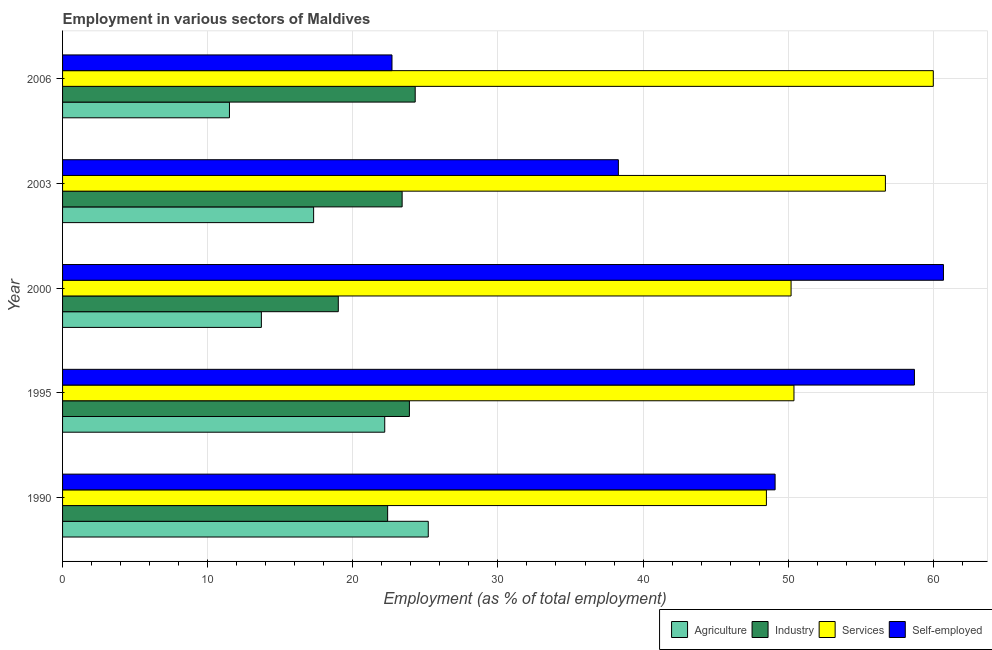How many bars are there on the 3rd tick from the bottom?
Your response must be concise. 4. In how many cases, is the number of bars for a given year not equal to the number of legend labels?
Keep it short and to the point. 0. What is the percentage of workers in agriculture in 1990?
Your answer should be very brief. 25.2. Across all years, what is the maximum percentage of workers in industry?
Give a very brief answer. 24.3. Across all years, what is the minimum percentage of self employed workers?
Offer a very short reply. 22.7. In which year was the percentage of workers in agriculture maximum?
Provide a short and direct response. 1990. What is the total percentage of workers in industry in the graph?
Ensure brevity in your answer.  113. What is the difference between the percentage of workers in industry in 2000 and the percentage of workers in agriculture in 1990?
Your response must be concise. -6.2. What is the average percentage of workers in agriculture per year?
Give a very brief answer. 17.98. In how many years, is the percentage of workers in industry greater than 22 %?
Offer a terse response. 4. What is the ratio of the percentage of workers in services in 2000 to that in 2003?
Make the answer very short. 0.89. What is the difference between the highest and the second highest percentage of workers in industry?
Your response must be concise. 0.4. What is the difference between the highest and the lowest percentage of workers in agriculture?
Your response must be concise. 13.7. In how many years, is the percentage of workers in industry greater than the average percentage of workers in industry taken over all years?
Make the answer very short. 3. Is the sum of the percentage of self employed workers in 1995 and 2000 greater than the maximum percentage of workers in services across all years?
Your answer should be very brief. Yes. What does the 2nd bar from the top in 2003 represents?
Give a very brief answer. Services. What does the 4th bar from the bottom in 1990 represents?
Your response must be concise. Self-employed. How many bars are there?
Your answer should be compact. 20. How many years are there in the graph?
Your answer should be compact. 5. Does the graph contain grids?
Give a very brief answer. Yes. Where does the legend appear in the graph?
Your answer should be compact. Bottom right. How are the legend labels stacked?
Provide a succinct answer. Horizontal. What is the title of the graph?
Give a very brief answer. Employment in various sectors of Maldives. Does "Revenue mobilization" appear as one of the legend labels in the graph?
Ensure brevity in your answer.  No. What is the label or title of the X-axis?
Your answer should be compact. Employment (as % of total employment). What is the Employment (as % of total employment) in Agriculture in 1990?
Ensure brevity in your answer.  25.2. What is the Employment (as % of total employment) of Industry in 1990?
Give a very brief answer. 22.4. What is the Employment (as % of total employment) in Services in 1990?
Your answer should be compact. 48.5. What is the Employment (as % of total employment) in Self-employed in 1990?
Your response must be concise. 49.1. What is the Employment (as % of total employment) of Agriculture in 1995?
Offer a very short reply. 22.2. What is the Employment (as % of total employment) of Industry in 1995?
Make the answer very short. 23.9. What is the Employment (as % of total employment) of Services in 1995?
Provide a succinct answer. 50.4. What is the Employment (as % of total employment) in Self-employed in 1995?
Ensure brevity in your answer.  58.7. What is the Employment (as % of total employment) in Agriculture in 2000?
Keep it short and to the point. 13.7. What is the Employment (as % of total employment) in Services in 2000?
Make the answer very short. 50.2. What is the Employment (as % of total employment) in Self-employed in 2000?
Keep it short and to the point. 60.7. What is the Employment (as % of total employment) in Agriculture in 2003?
Give a very brief answer. 17.3. What is the Employment (as % of total employment) of Industry in 2003?
Your answer should be very brief. 23.4. What is the Employment (as % of total employment) in Services in 2003?
Your answer should be very brief. 56.7. What is the Employment (as % of total employment) in Self-employed in 2003?
Provide a succinct answer. 38.3. What is the Employment (as % of total employment) of Agriculture in 2006?
Keep it short and to the point. 11.5. What is the Employment (as % of total employment) in Industry in 2006?
Make the answer very short. 24.3. What is the Employment (as % of total employment) of Services in 2006?
Your response must be concise. 60. What is the Employment (as % of total employment) in Self-employed in 2006?
Give a very brief answer. 22.7. Across all years, what is the maximum Employment (as % of total employment) of Agriculture?
Give a very brief answer. 25.2. Across all years, what is the maximum Employment (as % of total employment) in Industry?
Keep it short and to the point. 24.3. Across all years, what is the maximum Employment (as % of total employment) in Self-employed?
Keep it short and to the point. 60.7. Across all years, what is the minimum Employment (as % of total employment) in Agriculture?
Your answer should be very brief. 11.5. Across all years, what is the minimum Employment (as % of total employment) in Industry?
Your answer should be very brief. 19. Across all years, what is the minimum Employment (as % of total employment) in Services?
Keep it short and to the point. 48.5. Across all years, what is the minimum Employment (as % of total employment) in Self-employed?
Provide a short and direct response. 22.7. What is the total Employment (as % of total employment) in Agriculture in the graph?
Your response must be concise. 89.9. What is the total Employment (as % of total employment) of Industry in the graph?
Your answer should be compact. 113. What is the total Employment (as % of total employment) of Services in the graph?
Ensure brevity in your answer.  265.8. What is the total Employment (as % of total employment) in Self-employed in the graph?
Ensure brevity in your answer.  229.5. What is the difference between the Employment (as % of total employment) of Agriculture in 1990 and that in 1995?
Offer a terse response. 3. What is the difference between the Employment (as % of total employment) in Industry in 1990 and that in 1995?
Offer a very short reply. -1.5. What is the difference between the Employment (as % of total employment) in Services in 1990 and that in 1995?
Your answer should be very brief. -1.9. What is the difference between the Employment (as % of total employment) in Industry in 1990 and that in 2000?
Ensure brevity in your answer.  3.4. What is the difference between the Employment (as % of total employment) of Agriculture in 1990 and that in 2003?
Ensure brevity in your answer.  7.9. What is the difference between the Employment (as % of total employment) of Services in 1990 and that in 2003?
Ensure brevity in your answer.  -8.2. What is the difference between the Employment (as % of total employment) in Industry in 1990 and that in 2006?
Provide a succinct answer. -1.9. What is the difference between the Employment (as % of total employment) of Services in 1990 and that in 2006?
Your answer should be compact. -11.5. What is the difference between the Employment (as % of total employment) in Self-employed in 1990 and that in 2006?
Your response must be concise. 26.4. What is the difference between the Employment (as % of total employment) of Industry in 1995 and that in 2000?
Offer a terse response. 4.9. What is the difference between the Employment (as % of total employment) of Industry in 1995 and that in 2003?
Offer a very short reply. 0.5. What is the difference between the Employment (as % of total employment) of Self-employed in 1995 and that in 2003?
Ensure brevity in your answer.  20.4. What is the difference between the Employment (as % of total employment) in Agriculture in 1995 and that in 2006?
Ensure brevity in your answer.  10.7. What is the difference between the Employment (as % of total employment) in Industry in 1995 and that in 2006?
Your response must be concise. -0.4. What is the difference between the Employment (as % of total employment) in Self-employed in 1995 and that in 2006?
Ensure brevity in your answer.  36. What is the difference between the Employment (as % of total employment) of Services in 2000 and that in 2003?
Your response must be concise. -6.5. What is the difference between the Employment (as % of total employment) in Self-employed in 2000 and that in 2003?
Keep it short and to the point. 22.4. What is the difference between the Employment (as % of total employment) of Agriculture in 2000 and that in 2006?
Provide a succinct answer. 2.2. What is the difference between the Employment (as % of total employment) of Self-employed in 2000 and that in 2006?
Provide a succinct answer. 38. What is the difference between the Employment (as % of total employment) of Agriculture in 2003 and that in 2006?
Make the answer very short. 5.8. What is the difference between the Employment (as % of total employment) in Industry in 2003 and that in 2006?
Keep it short and to the point. -0.9. What is the difference between the Employment (as % of total employment) in Services in 2003 and that in 2006?
Give a very brief answer. -3.3. What is the difference between the Employment (as % of total employment) in Agriculture in 1990 and the Employment (as % of total employment) in Industry in 1995?
Offer a terse response. 1.3. What is the difference between the Employment (as % of total employment) in Agriculture in 1990 and the Employment (as % of total employment) in Services in 1995?
Give a very brief answer. -25.2. What is the difference between the Employment (as % of total employment) in Agriculture in 1990 and the Employment (as % of total employment) in Self-employed in 1995?
Offer a terse response. -33.5. What is the difference between the Employment (as % of total employment) of Industry in 1990 and the Employment (as % of total employment) of Self-employed in 1995?
Offer a terse response. -36.3. What is the difference between the Employment (as % of total employment) in Services in 1990 and the Employment (as % of total employment) in Self-employed in 1995?
Offer a very short reply. -10.2. What is the difference between the Employment (as % of total employment) in Agriculture in 1990 and the Employment (as % of total employment) in Industry in 2000?
Your response must be concise. 6.2. What is the difference between the Employment (as % of total employment) of Agriculture in 1990 and the Employment (as % of total employment) of Self-employed in 2000?
Offer a terse response. -35.5. What is the difference between the Employment (as % of total employment) in Industry in 1990 and the Employment (as % of total employment) in Services in 2000?
Give a very brief answer. -27.8. What is the difference between the Employment (as % of total employment) in Industry in 1990 and the Employment (as % of total employment) in Self-employed in 2000?
Give a very brief answer. -38.3. What is the difference between the Employment (as % of total employment) in Services in 1990 and the Employment (as % of total employment) in Self-employed in 2000?
Give a very brief answer. -12.2. What is the difference between the Employment (as % of total employment) of Agriculture in 1990 and the Employment (as % of total employment) of Industry in 2003?
Make the answer very short. 1.8. What is the difference between the Employment (as % of total employment) in Agriculture in 1990 and the Employment (as % of total employment) in Services in 2003?
Offer a very short reply. -31.5. What is the difference between the Employment (as % of total employment) of Industry in 1990 and the Employment (as % of total employment) of Services in 2003?
Your answer should be compact. -34.3. What is the difference between the Employment (as % of total employment) of Industry in 1990 and the Employment (as % of total employment) of Self-employed in 2003?
Make the answer very short. -15.9. What is the difference between the Employment (as % of total employment) of Agriculture in 1990 and the Employment (as % of total employment) of Industry in 2006?
Offer a terse response. 0.9. What is the difference between the Employment (as % of total employment) in Agriculture in 1990 and the Employment (as % of total employment) in Services in 2006?
Your answer should be compact. -34.8. What is the difference between the Employment (as % of total employment) in Agriculture in 1990 and the Employment (as % of total employment) in Self-employed in 2006?
Keep it short and to the point. 2.5. What is the difference between the Employment (as % of total employment) of Industry in 1990 and the Employment (as % of total employment) of Services in 2006?
Provide a succinct answer. -37.6. What is the difference between the Employment (as % of total employment) of Services in 1990 and the Employment (as % of total employment) of Self-employed in 2006?
Offer a terse response. 25.8. What is the difference between the Employment (as % of total employment) in Agriculture in 1995 and the Employment (as % of total employment) in Industry in 2000?
Your answer should be very brief. 3.2. What is the difference between the Employment (as % of total employment) of Agriculture in 1995 and the Employment (as % of total employment) of Services in 2000?
Ensure brevity in your answer.  -28. What is the difference between the Employment (as % of total employment) in Agriculture in 1995 and the Employment (as % of total employment) in Self-employed in 2000?
Offer a very short reply. -38.5. What is the difference between the Employment (as % of total employment) of Industry in 1995 and the Employment (as % of total employment) of Services in 2000?
Your answer should be compact. -26.3. What is the difference between the Employment (as % of total employment) of Industry in 1995 and the Employment (as % of total employment) of Self-employed in 2000?
Give a very brief answer. -36.8. What is the difference between the Employment (as % of total employment) in Agriculture in 1995 and the Employment (as % of total employment) in Services in 2003?
Your answer should be compact. -34.5. What is the difference between the Employment (as % of total employment) in Agriculture in 1995 and the Employment (as % of total employment) in Self-employed in 2003?
Your response must be concise. -16.1. What is the difference between the Employment (as % of total employment) in Industry in 1995 and the Employment (as % of total employment) in Services in 2003?
Offer a terse response. -32.8. What is the difference between the Employment (as % of total employment) in Industry in 1995 and the Employment (as % of total employment) in Self-employed in 2003?
Provide a succinct answer. -14.4. What is the difference between the Employment (as % of total employment) of Services in 1995 and the Employment (as % of total employment) of Self-employed in 2003?
Provide a succinct answer. 12.1. What is the difference between the Employment (as % of total employment) in Agriculture in 1995 and the Employment (as % of total employment) in Industry in 2006?
Your answer should be very brief. -2.1. What is the difference between the Employment (as % of total employment) of Agriculture in 1995 and the Employment (as % of total employment) of Services in 2006?
Ensure brevity in your answer.  -37.8. What is the difference between the Employment (as % of total employment) in Industry in 1995 and the Employment (as % of total employment) in Services in 2006?
Offer a terse response. -36.1. What is the difference between the Employment (as % of total employment) in Services in 1995 and the Employment (as % of total employment) in Self-employed in 2006?
Provide a short and direct response. 27.7. What is the difference between the Employment (as % of total employment) in Agriculture in 2000 and the Employment (as % of total employment) in Industry in 2003?
Make the answer very short. -9.7. What is the difference between the Employment (as % of total employment) of Agriculture in 2000 and the Employment (as % of total employment) of Services in 2003?
Your response must be concise. -43. What is the difference between the Employment (as % of total employment) of Agriculture in 2000 and the Employment (as % of total employment) of Self-employed in 2003?
Give a very brief answer. -24.6. What is the difference between the Employment (as % of total employment) of Industry in 2000 and the Employment (as % of total employment) of Services in 2003?
Provide a succinct answer. -37.7. What is the difference between the Employment (as % of total employment) in Industry in 2000 and the Employment (as % of total employment) in Self-employed in 2003?
Ensure brevity in your answer.  -19.3. What is the difference between the Employment (as % of total employment) in Agriculture in 2000 and the Employment (as % of total employment) in Services in 2006?
Your response must be concise. -46.3. What is the difference between the Employment (as % of total employment) of Industry in 2000 and the Employment (as % of total employment) of Services in 2006?
Provide a short and direct response. -41. What is the difference between the Employment (as % of total employment) in Industry in 2000 and the Employment (as % of total employment) in Self-employed in 2006?
Make the answer very short. -3.7. What is the difference between the Employment (as % of total employment) of Agriculture in 2003 and the Employment (as % of total employment) of Industry in 2006?
Ensure brevity in your answer.  -7. What is the difference between the Employment (as % of total employment) in Agriculture in 2003 and the Employment (as % of total employment) in Services in 2006?
Provide a succinct answer. -42.7. What is the difference between the Employment (as % of total employment) in Industry in 2003 and the Employment (as % of total employment) in Services in 2006?
Make the answer very short. -36.6. What is the difference between the Employment (as % of total employment) in Services in 2003 and the Employment (as % of total employment) in Self-employed in 2006?
Offer a terse response. 34. What is the average Employment (as % of total employment) in Agriculture per year?
Give a very brief answer. 17.98. What is the average Employment (as % of total employment) in Industry per year?
Ensure brevity in your answer.  22.6. What is the average Employment (as % of total employment) of Services per year?
Provide a short and direct response. 53.16. What is the average Employment (as % of total employment) in Self-employed per year?
Provide a short and direct response. 45.9. In the year 1990, what is the difference between the Employment (as % of total employment) in Agriculture and Employment (as % of total employment) in Services?
Offer a terse response. -23.3. In the year 1990, what is the difference between the Employment (as % of total employment) in Agriculture and Employment (as % of total employment) in Self-employed?
Offer a very short reply. -23.9. In the year 1990, what is the difference between the Employment (as % of total employment) in Industry and Employment (as % of total employment) in Services?
Give a very brief answer. -26.1. In the year 1990, what is the difference between the Employment (as % of total employment) in Industry and Employment (as % of total employment) in Self-employed?
Your answer should be compact. -26.7. In the year 1990, what is the difference between the Employment (as % of total employment) of Services and Employment (as % of total employment) of Self-employed?
Offer a very short reply. -0.6. In the year 1995, what is the difference between the Employment (as % of total employment) in Agriculture and Employment (as % of total employment) in Services?
Your answer should be compact. -28.2. In the year 1995, what is the difference between the Employment (as % of total employment) in Agriculture and Employment (as % of total employment) in Self-employed?
Keep it short and to the point. -36.5. In the year 1995, what is the difference between the Employment (as % of total employment) of Industry and Employment (as % of total employment) of Services?
Provide a short and direct response. -26.5. In the year 1995, what is the difference between the Employment (as % of total employment) in Industry and Employment (as % of total employment) in Self-employed?
Give a very brief answer. -34.8. In the year 1995, what is the difference between the Employment (as % of total employment) of Services and Employment (as % of total employment) of Self-employed?
Offer a very short reply. -8.3. In the year 2000, what is the difference between the Employment (as % of total employment) of Agriculture and Employment (as % of total employment) of Industry?
Keep it short and to the point. -5.3. In the year 2000, what is the difference between the Employment (as % of total employment) of Agriculture and Employment (as % of total employment) of Services?
Your response must be concise. -36.5. In the year 2000, what is the difference between the Employment (as % of total employment) in Agriculture and Employment (as % of total employment) in Self-employed?
Ensure brevity in your answer.  -47. In the year 2000, what is the difference between the Employment (as % of total employment) in Industry and Employment (as % of total employment) in Services?
Keep it short and to the point. -31.2. In the year 2000, what is the difference between the Employment (as % of total employment) of Industry and Employment (as % of total employment) of Self-employed?
Your answer should be very brief. -41.7. In the year 2000, what is the difference between the Employment (as % of total employment) in Services and Employment (as % of total employment) in Self-employed?
Offer a terse response. -10.5. In the year 2003, what is the difference between the Employment (as % of total employment) in Agriculture and Employment (as % of total employment) in Services?
Provide a succinct answer. -39.4. In the year 2003, what is the difference between the Employment (as % of total employment) in Industry and Employment (as % of total employment) in Services?
Keep it short and to the point. -33.3. In the year 2003, what is the difference between the Employment (as % of total employment) in Industry and Employment (as % of total employment) in Self-employed?
Your answer should be compact. -14.9. In the year 2003, what is the difference between the Employment (as % of total employment) in Services and Employment (as % of total employment) in Self-employed?
Your answer should be compact. 18.4. In the year 2006, what is the difference between the Employment (as % of total employment) of Agriculture and Employment (as % of total employment) of Industry?
Give a very brief answer. -12.8. In the year 2006, what is the difference between the Employment (as % of total employment) of Agriculture and Employment (as % of total employment) of Services?
Offer a very short reply. -48.5. In the year 2006, what is the difference between the Employment (as % of total employment) in Industry and Employment (as % of total employment) in Services?
Offer a very short reply. -35.7. In the year 2006, what is the difference between the Employment (as % of total employment) of Industry and Employment (as % of total employment) of Self-employed?
Your answer should be compact. 1.6. In the year 2006, what is the difference between the Employment (as % of total employment) in Services and Employment (as % of total employment) in Self-employed?
Provide a short and direct response. 37.3. What is the ratio of the Employment (as % of total employment) of Agriculture in 1990 to that in 1995?
Provide a short and direct response. 1.14. What is the ratio of the Employment (as % of total employment) in Industry in 1990 to that in 1995?
Your response must be concise. 0.94. What is the ratio of the Employment (as % of total employment) in Services in 1990 to that in 1995?
Ensure brevity in your answer.  0.96. What is the ratio of the Employment (as % of total employment) of Self-employed in 1990 to that in 1995?
Keep it short and to the point. 0.84. What is the ratio of the Employment (as % of total employment) of Agriculture in 1990 to that in 2000?
Give a very brief answer. 1.84. What is the ratio of the Employment (as % of total employment) of Industry in 1990 to that in 2000?
Offer a very short reply. 1.18. What is the ratio of the Employment (as % of total employment) in Services in 1990 to that in 2000?
Give a very brief answer. 0.97. What is the ratio of the Employment (as % of total employment) of Self-employed in 1990 to that in 2000?
Your response must be concise. 0.81. What is the ratio of the Employment (as % of total employment) in Agriculture in 1990 to that in 2003?
Ensure brevity in your answer.  1.46. What is the ratio of the Employment (as % of total employment) of Industry in 1990 to that in 2003?
Keep it short and to the point. 0.96. What is the ratio of the Employment (as % of total employment) of Services in 1990 to that in 2003?
Give a very brief answer. 0.86. What is the ratio of the Employment (as % of total employment) in Self-employed in 1990 to that in 2003?
Give a very brief answer. 1.28. What is the ratio of the Employment (as % of total employment) in Agriculture in 1990 to that in 2006?
Your answer should be very brief. 2.19. What is the ratio of the Employment (as % of total employment) in Industry in 1990 to that in 2006?
Make the answer very short. 0.92. What is the ratio of the Employment (as % of total employment) of Services in 1990 to that in 2006?
Your response must be concise. 0.81. What is the ratio of the Employment (as % of total employment) of Self-employed in 1990 to that in 2006?
Offer a very short reply. 2.16. What is the ratio of the Employment (as % of total employment) in Agriculture in 1995 to that in 2000?
Offer a very short reply. 1.62. What is the ratio of the Employment (as % of total employment) in Industry in 1995 to that in 2000?
Your answer should be very brief. 1.26. What is the ratio of the Employment (as % of total employment) of Services in 1995 to that in 2000?
Your response must be concise. 1. What is the ratio of the Employment (as % of total employment) of Self-employed in 1995 to that in 2000?
Your answer should be very brief. 0.97. What is the ratio of the Employment (as % of total employment) of Agriculture in 1995 to that in 2003?
Your answer should be very brief. 1.28. What is the ratio of the Employment (as % of total employment) in Industry in 1995 to that in 2003?
Your answer should be compact. 1.02. What is the ratio of the Employment (as % of total employment) of Self-employed in 1995 to that in 2003?
Offer a very short reply. 1.53. What is the ratio of the Employment (as % of total employment) in Agriculture in 1995 to that in 2006?
Your answer should be compact. 1.93. What is the ratio of the Employment (as % of total employment) of Industry in 1995 to that in 2006?
Ensure brevity in your answer.  0.98. What is the ratio of the Employment (as % of total employment) in Services in 1995 to that in 2006?
Make the answer very short. 0.84. What is the ratio of the Employment (as % of total employment) in Self-employed in 1995 to that in 2006?
Your response must be concise. 2.59. What is the ratio of the Employment (as % of total employment) of Agriculture in 2000 to that in 2003?
Your answer should be very brief. 0.79. What is the ratio of the Employment (as % of total employment) of Industry in 2000 to that in 2003?
Ensure brevity in your answer.  0.81. What is the ratio of the Employment (as % of total employment) of Services in 2000 to that in 2003?
Give a very brief answer. 0.89. What is the ratio of the Employment (as % of total employment) in Self-employed in 2000 to that in 2003?
Provide a short and direct response. 1.58. What is the ratio of the Employment (as % of total employment) in Agriculture in 2000 to that in 2006?
Make the answer very short. 1.19. What is the ratio of the Employment (as % of total employment) in Industry in 2000 to that in 2006?
Ensure brevity in your answer.  0.78. What is the ratio of the Employment (as % of total employment) of Services in 2000 to that in 2006?
Offer a very short reply. 0.84. What is the ratio of the Employment (as % of total employment) of Self-employed in 2000 to that in 2006?
Your answer should be compact. 2.67. What is the ratio of the Employment (as % of total employment) in Agriculture in 2003 to that in 2006?
Provide a succinct answer. 1.5. What is the ratio of the Employment (as % of total employment) of Services in 2003 to that in 2006?
Make the answer very short. 0.94. What is the ratio of the Employment (as % of total employment) in Self-employed in 2003 to that in 2006?
Provide a short and direct response. 1.69. What is the difference between the highest and the second highest Employment (as % of total employment) of Agriculture?
Your answer should be compact. 3. What is the difference between the highest and the lowest Employment (as % of total employment) in Agriculture?
Make the answer very short. 13.7. What is the difference between the highest and the lowest Employment (as % of total employment) in Services?
Provide a succinct answer. 11.5. What is the difference between the highest and the lowest Employment (as % of total employment) in Self-employed?
Ensure brevity in your answer.  38. 